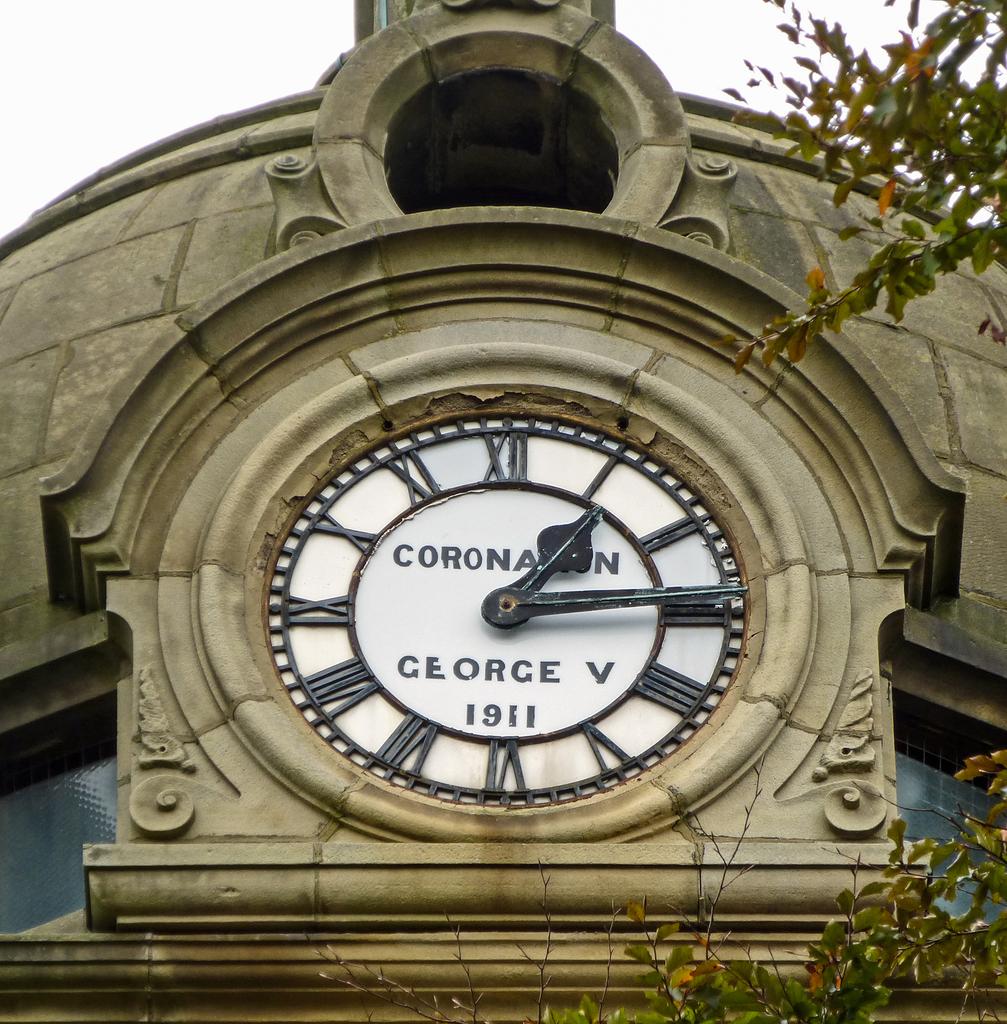What does this clock say?
Give a very brief answer. Coronation george v 1911. 